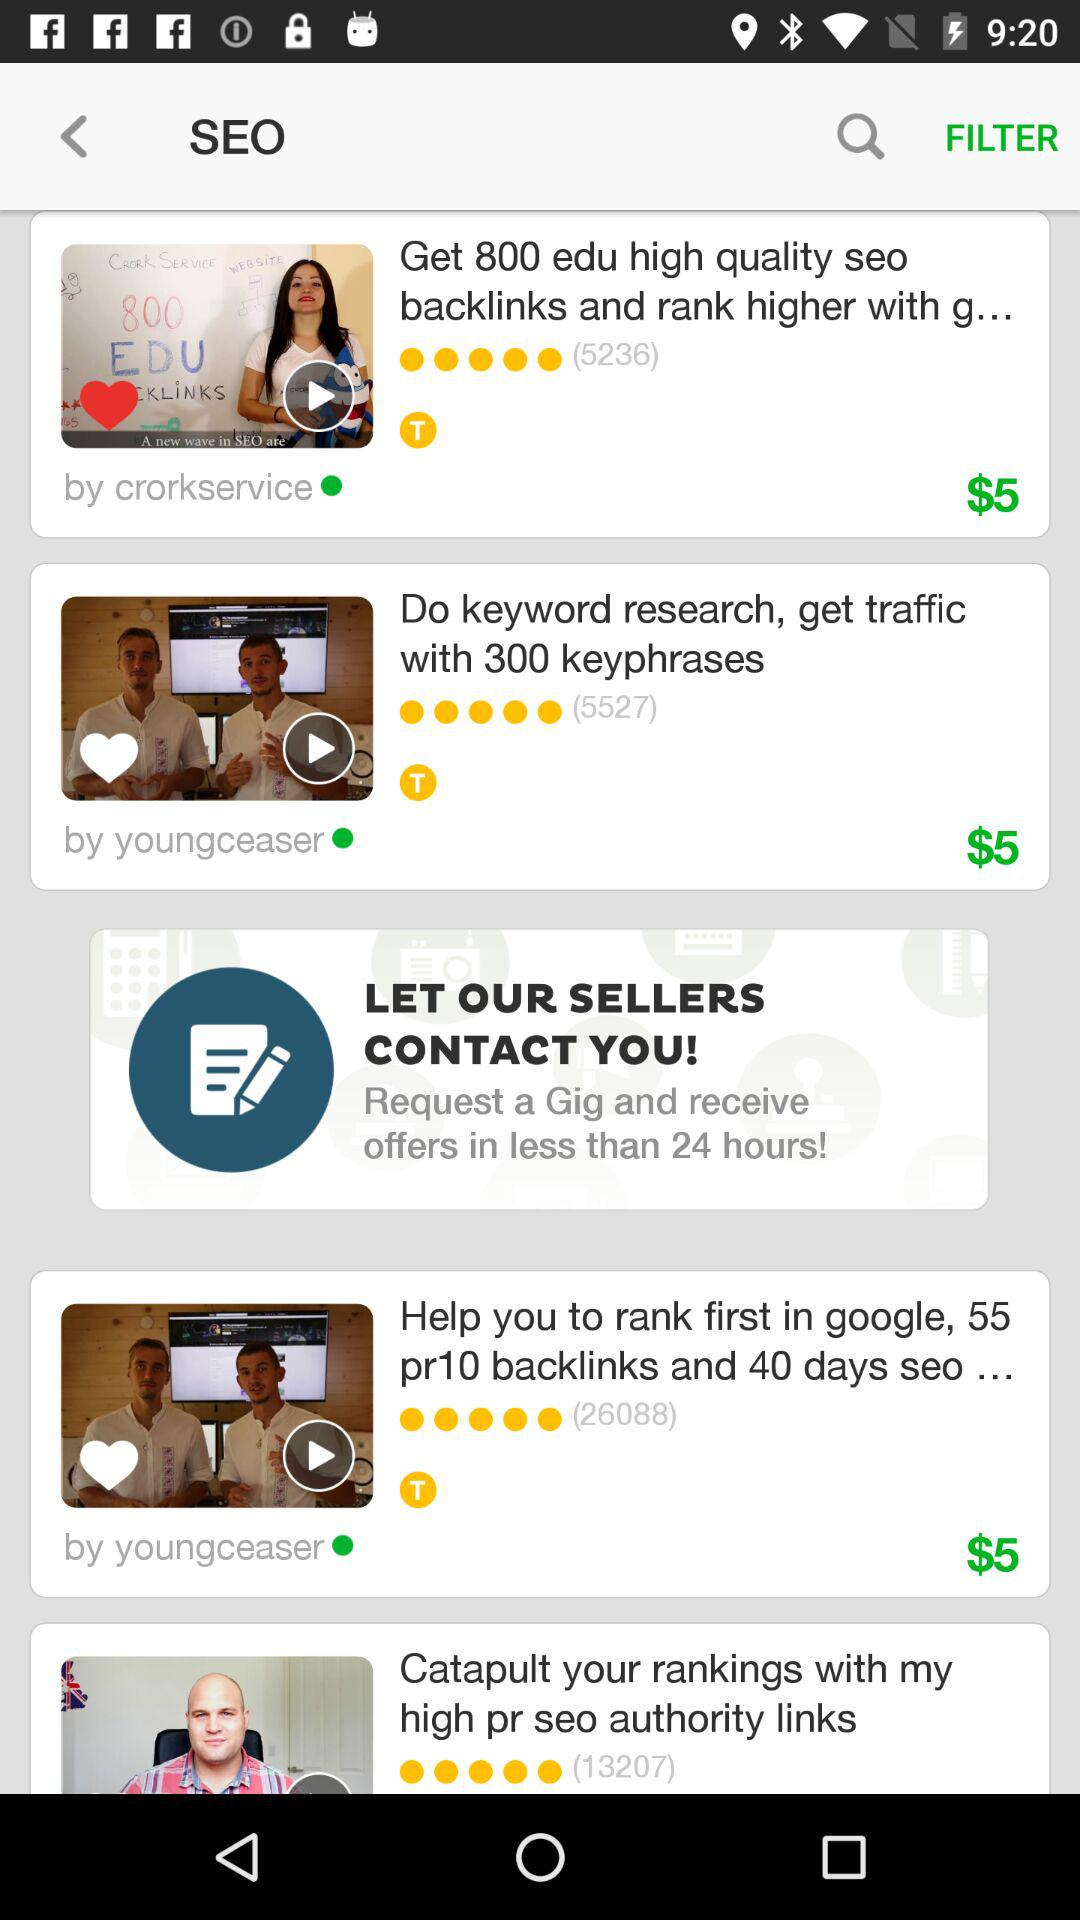What is the application name? The application name is "SEO". 